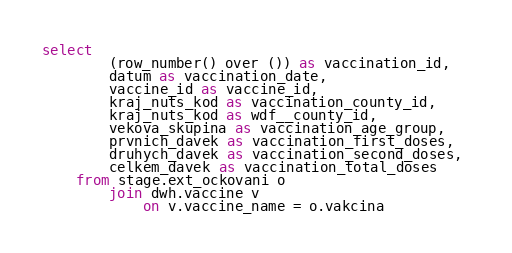Convert code to text. <code><loc_0><loc_0><loc_500><loc_500><_SQL_>select 
		(row_number() over ()) as vaccination_id, 
		datum as vaccination_date, 
		vaccine_id as vaccine_id, 
		kraj_nuts_kod as vaccination_county_id, 
		kraj_nuts_kod as wdf__county_id, 
		vekova_skupina as vaccination_age_group, 
		prvnich_davek as vaccination_first_doses, 
		druhych_davek as vaccination_second_doses, 
		celkem_davek as vaccination_total_doses 
	from stage.ext_ockovani o 
        join dwh.vaccine v 
            on v.vaccine_name = o.vakcina</code> 